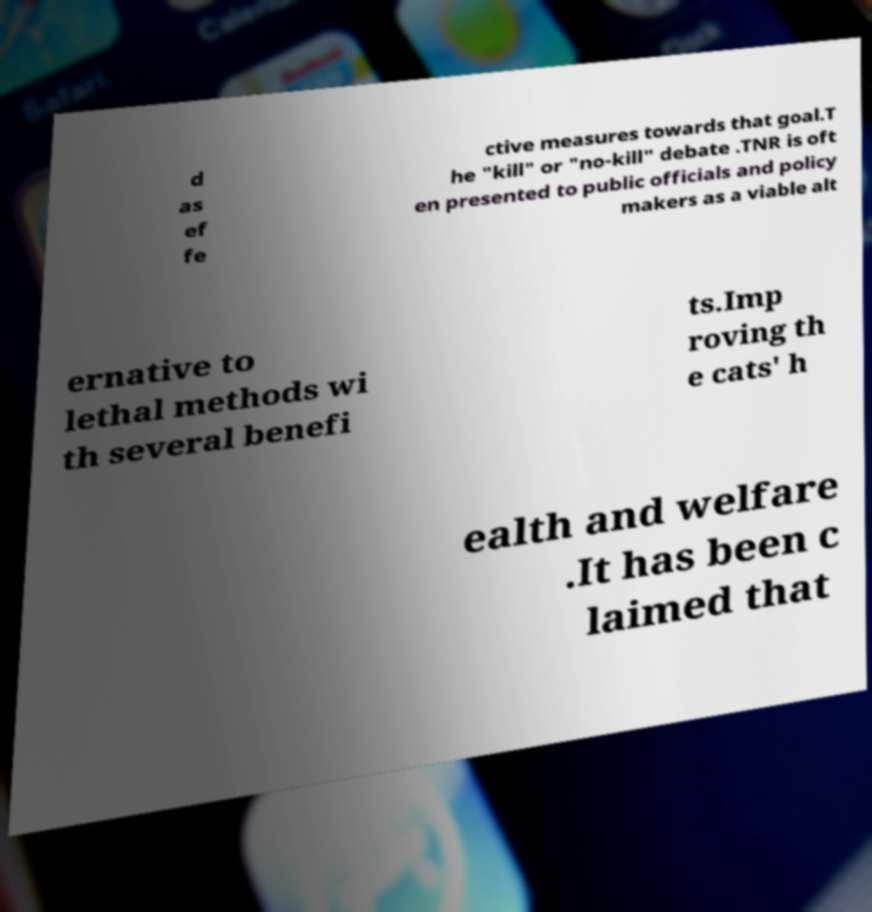Can you accurately transcribe the text from the provided image for me? d as ef fe ctive measures towards that goal.T he "kill" or "no-kill" debate .TNR is oft en presented to public officials and policy makers as a viable alt ernative to lethal methods wi th several benefi ts.Imp roving th e cats' h ealth and welfare .It has been c laimed that 